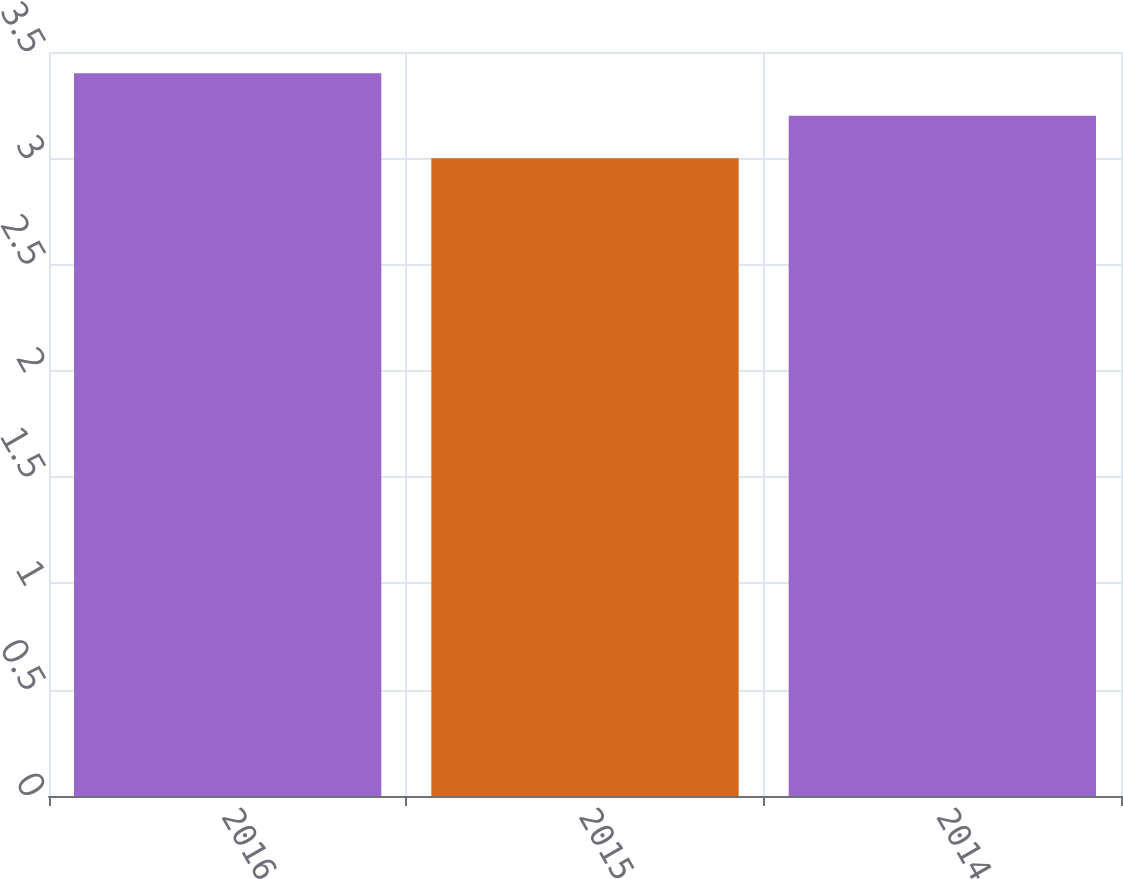Convert chart to OTSL. <chart><loc_0><loc_0><loc_500><loc_500><bar_chart><fcel>2016<fcel>2015<fcel>2014<nl><fcel>3.4<fcel>3<fcel>3.2<nl></chart> 